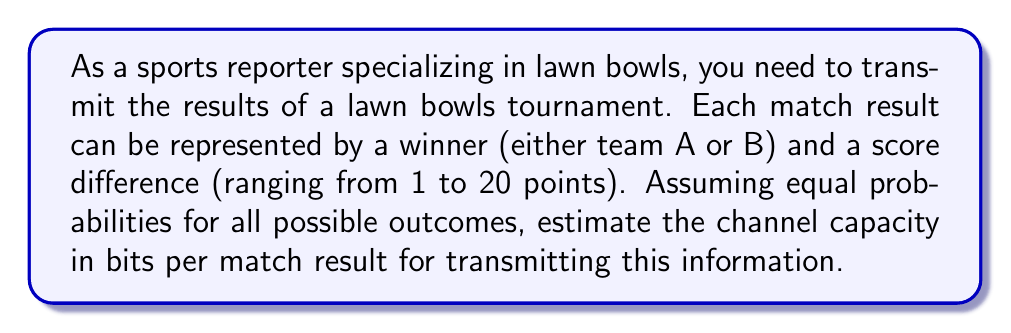What is the answer to this math problem? To estimate the channel capacity, we need to calculate the amount of information contained in each match result. Let's break this down step-by-step:

1. Possible outcomes:
   - Winner: 2 possibilities (Team A or Team B)
   - Score difference: 20 possibilities (1 to 20 points)

2. Total number of possible outcomes:
   $N = 2 \times 20 = 40$

3. Assuming equal probabilities for all outcomes, the probability of each outcome is:
   $p = \frac{1}{N} = \frac{1}{40}$

4. The information content of each match result can be calculated using the entropy formula:
   $$H = -\sum_{i=1}^N p_i \log_2(p_i)$$

   Since all probabilities are equal, we can simplify this to:
   $$H = -N \cdot p \log_2(p)$$

5. Substituting the values:
   $$\begin{align}
   H &= -40 \cdot \frac{1}{40} \log_2(\frac{1}{40}) \\
   &= -\log_2(\frac{1}{40}) \\
   &= \log_2(40) \\
   &\approx 5.3219 \text{ bits}
   \end{align}$$

6. The channel capacity is the maximum information that can be transmitted per match result, which is equal to the entropy in this case of equally probable outcomes.

Therefore, the estimated channel capacity for transmitting lawn bowls match results is approximately 5.3219 bits per match result.
Answer: The estimated channel capacity is approximately 5.3219 bits per match result. 